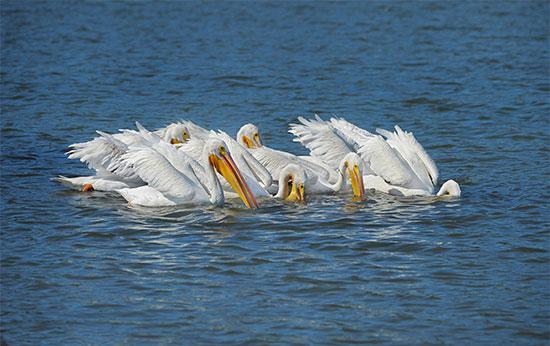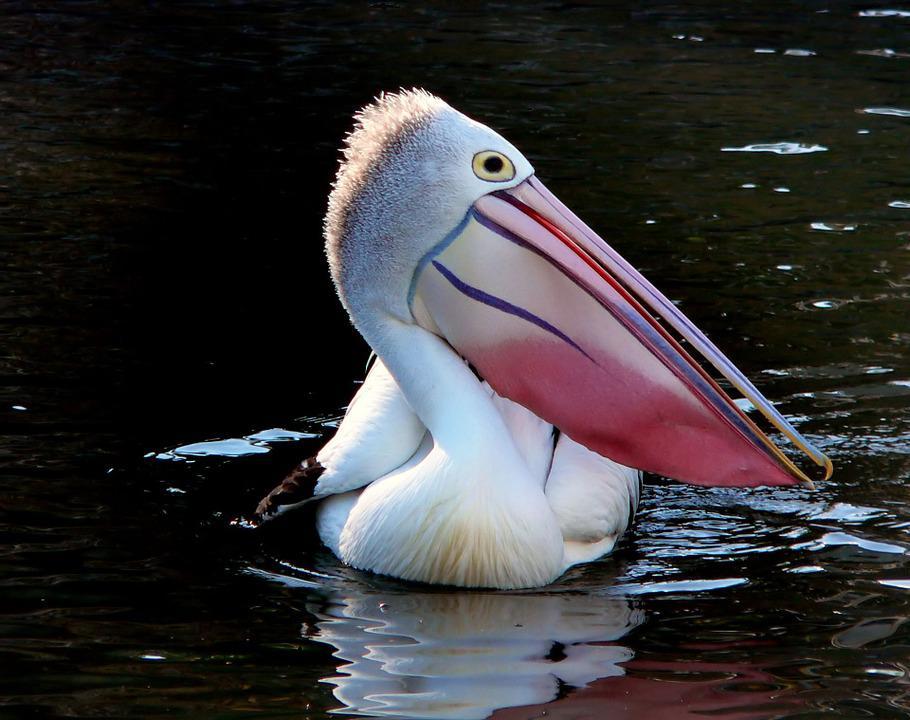The first image is the image on the left, the second image is the image on the right. Analyze the images presented: Is the assertion "One of the birds has its wings spread." valid? Answer yes or no. No. 